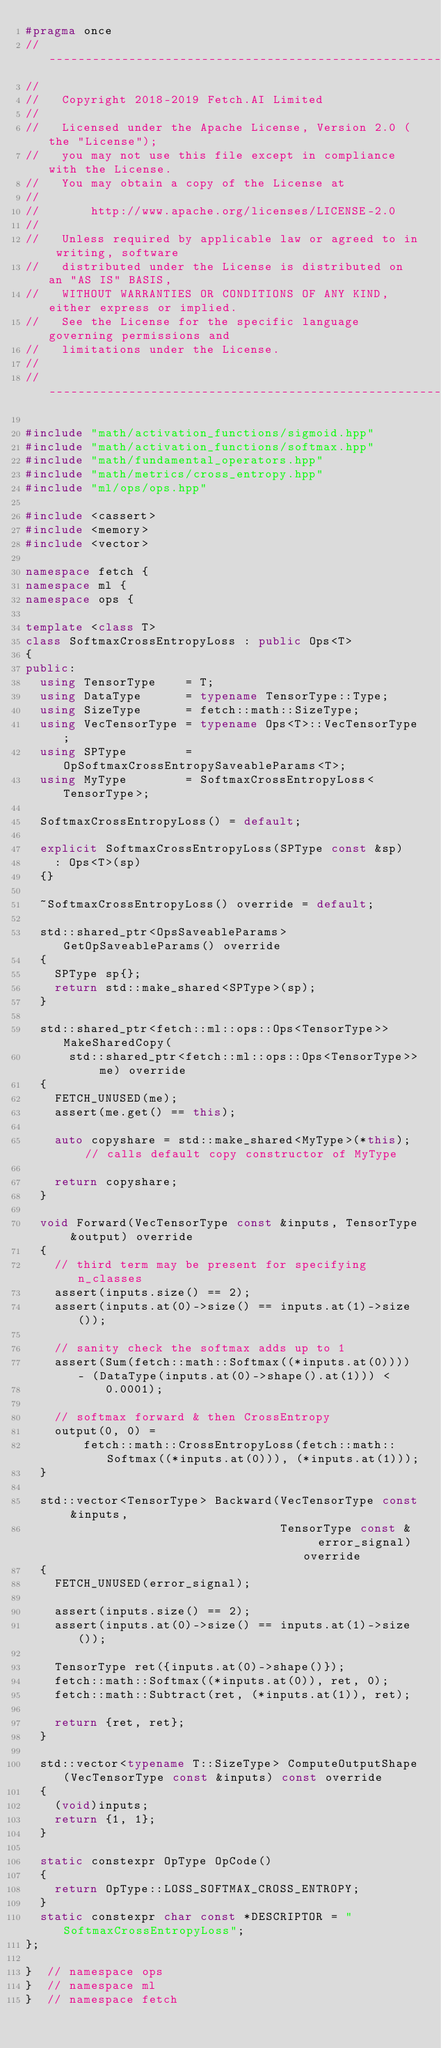<code> <loc_0><loc_0><loc_500><loc_500><_C++_>#pragma once
//------------------------------------------------------------------------------
//
//   Copyright 2018-2019 Fetch.AI Limited
//
//   Licensed under the Apache License, Version 2.0 (the "License");
//   you may not use this file except in compliance with the License.
//   You may obtain a copy of the License at
//
//       http://www.apache.org/licenses/LICENSE-2.0
//
//   Unless required by applicable law or agreed to in writing, software
//   distributed under the License is distributed on an "AS IS" BASIS,
//   WITHOUT WARRANTIES OR CONDITIONS OF ANY KIND, either express or implied.
//   See the License for the specific language governing permissions and
//   limitations under the License.
//
//------------------------------------------------------------------------------

#include "math/activation_functions/sigmoid.hpp"
#include "math/activation_functions/softmax.hpp"
#include "math/fundamental_operators.hpp"
#include "math/metrics/cross_entropy.hpp"
#include "ml/ops/ops.hpp"

#include <cassert>
#include <memory>
#include <vector>

namespace fetch {
namespace ml {
namespace ops {

template <class T>
class SoftmaxCrossEntropyLoss : public Ops<T>
{
public:
  using TensorType    = T;
  using DataType      = typename TensorType::Type;
  using SizeType      = fetch::math::SizeType;
  using VecTensorType = typename Ops<T>::VecTensorType;
  using SPType        = OpSoftmaxCrossEntropySaveableParams<T>;
  using MyType        = SoftmaxCrossEntropyLoss<TensorType>;

  SoftmaxCrossEntropyLoss() = default;

  explicit SoftmaxCrossEntropyLoss(SPType const &sp)
    : Ops<T>(sp)
  {}

  ~SoftmaxCrossEntropyLoss() override = default;

  std::shared_ptr<OpsSaveableParams> GetOpSaveableParams() override
  {
    SPType sp{};
    return std::make_shared<SPType>(sp);
  }

  std::shared_ptr<fetch::ml::ops::Ops<TensorType>> MakeSharedCopy(
      std::shared_ptr<fetch::ml::ops::Ops<TensorType>> me) override
  {
    FETCH_UNUSED(me);
    assert(me.get() == this);

    auto copyshare = std::make_shared<MyType>(*this);  // calls default copy constructor of MyType

    return copyshare;
  }

  void Forward(VecTensorType const &inputs, TensorType &output) override
  {
    // third term may be present for specifying n_classes
    assert(inputs.size() == 2);
    assert(inputs.at(0)->size() == inputs.at(1)->size());

    // sanity check the softmax adds up to 1
    assert(Sum(fetch::math::Softmax((*inputs.at(0)))) - (DataType(inputs.at(0)->shape().at(1))) <
           0.0001);

    // softmax forward & then CrossEntropy
    output(0, 0) =
        fetch::math::CrossEntropyLoss(fetch::math::Softmax((*inputs.at(0))), (*inputs.at(1)));
  }

  std::vector<TensorType> Backward(VecTensorType const &inputs,
                                   TensorType const &   error_signal) override
  {
    FETCH_UNUSED(error_signal);

    assert(inputs.size() == 2);
    assert(inputs.at(0)->size() == inputs.at(1)->size());

    TensorType ret({inputs.at(0)->shape()});
    fetch::math::Softmax((*inputs.at(0)), ret, 0);
    fetch::math::Subtract(ret, (*inputs.at(1)), ret);

    return {ret, ret};
  }

  std::vector<typename T::SizeType> ComputeOutputShape(VecTensorType const &inputs) const override
  {
    (void)inputs;
    return {1, 1};
  }

  static constexpr OpType OpCode()
  {
    return OpType::LOSS_SOFTMAX_CROSS_ENTROPY;
  }
  static constexpr char const *DESCRIPTOR = "SoftmaxCrossEntropyLoss";
};

}  // namespace ops
}  // namespace ml
}  // namespace fetch
</code> 